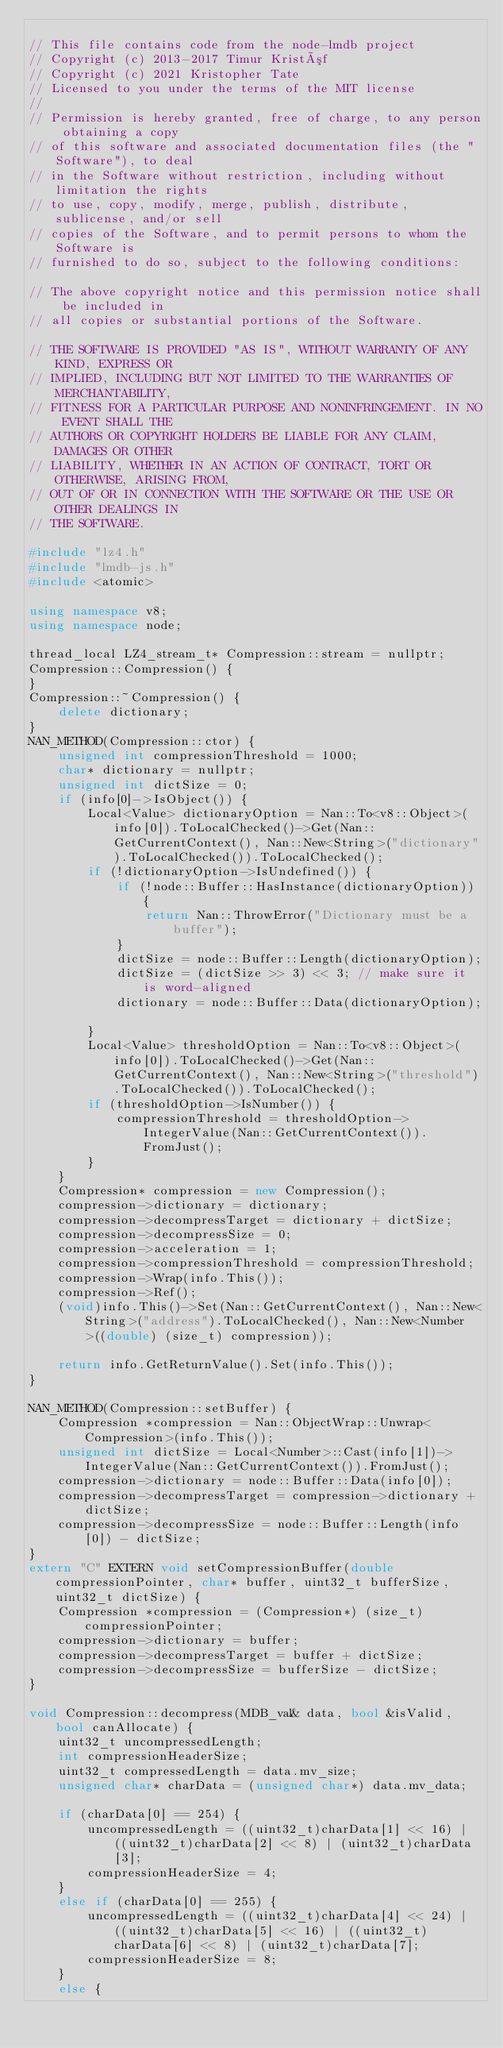Convert code to text. <code><loc_0><loc_0><loc_500><loc_500><_C++_>
// This file contains code from the node-lmdb project
// Copyright (c) 2013-2017 Timur Kristóf
// Copyright (c) 2021 Kristopher Tate
// Licensed to you under the terms of the MIT license
//
// Permission is hereby granted, free of charge, to any person obtaining a copy
// of this software and associated documentation files (the "Software"), to deal
// in the Software without restriction, including without limitation the rights
// to use, copy, modify, merge, publish, distribute, sublicense, and/or sell
// copies of the Software, and to permit persons to whom the Software is
// furnished to do so, subject to the following conditions:

// The above copyright notice and this permission notice shall be included in
// all copies or substantial portions of the Software.

// THE SOFTWARE IS PROVIDED "AS IS", WITHOUT WARRANTY OF ANY KIND, EXPRESS OR
// IMPLIED, INCLUDING BUT NOT LIMITED TO THE WARRANTIES OF MERCHANTABILITY,
// FITNESS FOR A PARTICULAR PURPOSE AND NONINFRINGEMENT. IN NO EVENT SHALL THE
// AUTHORS OR COPYRIGHT HOLDERS BE LIABLE FOR ANY CLAIM, DAMAGES OR OTHER
// LIABILITY, WHETHER IN AN ACTION OF CONTRACT, TORT OR OTHERWISE, ARISING FROM,
// OUT OF OR IN CONNECTION WITH THE SOFTWARE OR THE USE OR OTHER DEALINGS IN
// THE SOFTWARE.

#include "lz4.h"
#include "lmdb-js.h"
#include <atomic>

using namespace v8;
using namespace node;

thread_local LZ4_stream_t* Compression::stream = nullptr;
Compression::Compression() {
}
Compression::~Compression() {
    delete dictionary;
}
NAN_METHOD(Compression::ctor) {
    unsigned int compressionThreshold = 1000;
    char* dictionary = nullptr;
    unsigned int dictSize = 0;
    if (info[0]->IsObject()) {
        Local<Value> dictionaryOption = Nan::To<v8::Object>(info[0]).ToLocalChecked()->Get(Nan::GetCurrentContext(), Nan::New<String>("dictionary").ToLocalChecked()).ToLocalChecked();
        if (!dictionaryOption->IsUndefined()) {
            if (!node::Buffer::HasInstance(dictionaryOption)) {
                return Nan::ThrowError("Dictionary must be a buffer");
            }
            dictSize = node::Buffer::Length(dictionaryOption);
            dictSize = (dictSize >> 3) << 3; // make sure it is word-aligned
            dictionary = node::Buffer::Data(dictionaryOption);

        }
        Local<Value> thresholdOption = Nan::To<v8::Object>(info[0]).ToLocalChecked()->Get(Nan::GetCurrentContext(), Nan::New<String>("threshold").ToLocalChecked()).ToLocalChecked();
        if (thresholdOption->IsNumber()) {
            compressionThreshold = thresholdOption->IntegerValue(Nan::GetCurrentContext()).FromJust();
        }
    }
    Compression* compression = new Compression();
    compression->dictionary = dictionary;
    compression->decompressTarget = dictionary + dictSize;
    compression->decompressSize = 0;
    compression->acceleration = 1;
    compression->compressionThreshold = compressionThreshold;
    compression->Wrap(info.This());
    compression->Ref();
    (void)info.This()->Set(Nan::GetCurrentContext(), Nan::New<String>("address").ToLocalChecked(), Nan::New<Number>((double) (size_t) compression));

    return info.GetReturnValue().Set(info.This());
}

NAN_METHOD(Compression::setBuffer) {
    Compression *compression = Nan::ObjectWrap::Unwrap<Compression>(info.This());
    unsigned int dictSize = Local<Number>::Cast(info[1])->IntegerValue(Nan::GetCurrentContext()).FromJust();
    compression->dictionary = node::Buffer::Data(info[0]);
    compression->decompressTarget = compression->dictionary + dictSize;
    compression->decompressSize = node::Buffer::Length(info[0]) - dictSize;
}
extern "C" EXTERN void setCompressionBuffer(double compressionPointer, char* buffer, uint32_t bufferSize, uint32_t dictSize) {
    Compression *compression = (Compression*) (size_t) compressionPointer;
    compression->dictionary = buffer;
    compression->decompressTarget = buffer + dictSize;
    compression->decompressSize = bufferSize - dictSize;
}

void Compression::decompress(MDB_val& data, bool &isValid, bool canAllocate) {
    uint32_t uncompressedLength;
    int compressionHeaderSize;
    uint32_t compressedLength = data.mv_size;
    unsigned char* charData = (unsigned char*) data.mv_data;

    if (charData[0] == 254) {
        uncompressedLength = ((uint32_t)charData[1] << 16) | ((uint32_t)charData[2] << 8) | (uint32_t)charData[3];
        compressionHeaderSize = 4;
    }
    else if (charData[0] == 255) {
        uncompressedLength = ((uint32_t)charData[4] << 24) | ((uint32_t)charData[5] << 16) | ((uint32_t)charData[6] << 8) | (uint32_t)charData[7];
        compressionHeaderSize = 8;
    }
    else {</code> 